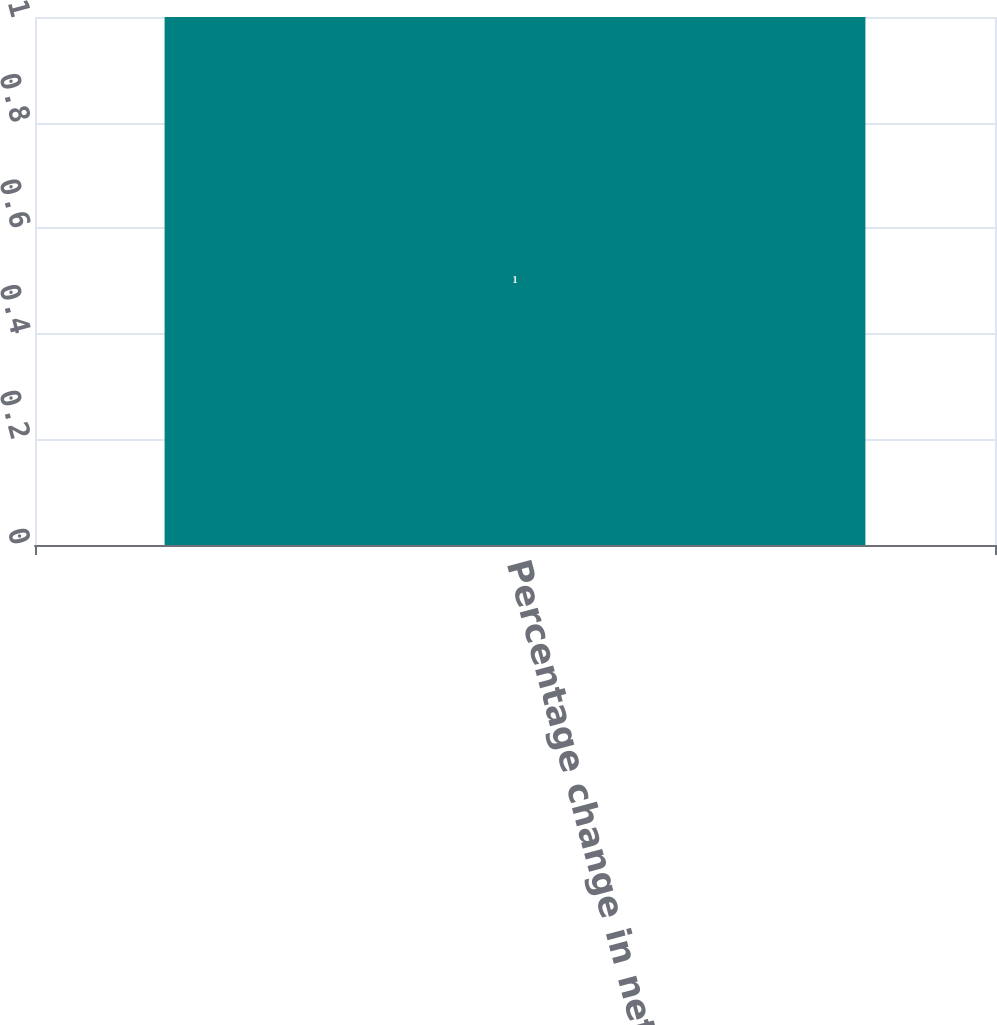Convert chart to OTSL. <chart><loc_0><loc_0><loc_500><loc_500><bar_chart><fcel>Percentage change in net sales<nl><fcel>1<nl></chart> 